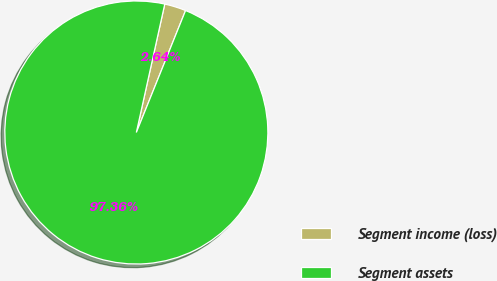Convert chart. <chart><loc_0><loc_0><loc_500><loc_500><pie_chart><fcel>Segment income (loss)<fcel>Segment assets<nl><fcel>2.64%<fcel>97.36%<nl></chart> 